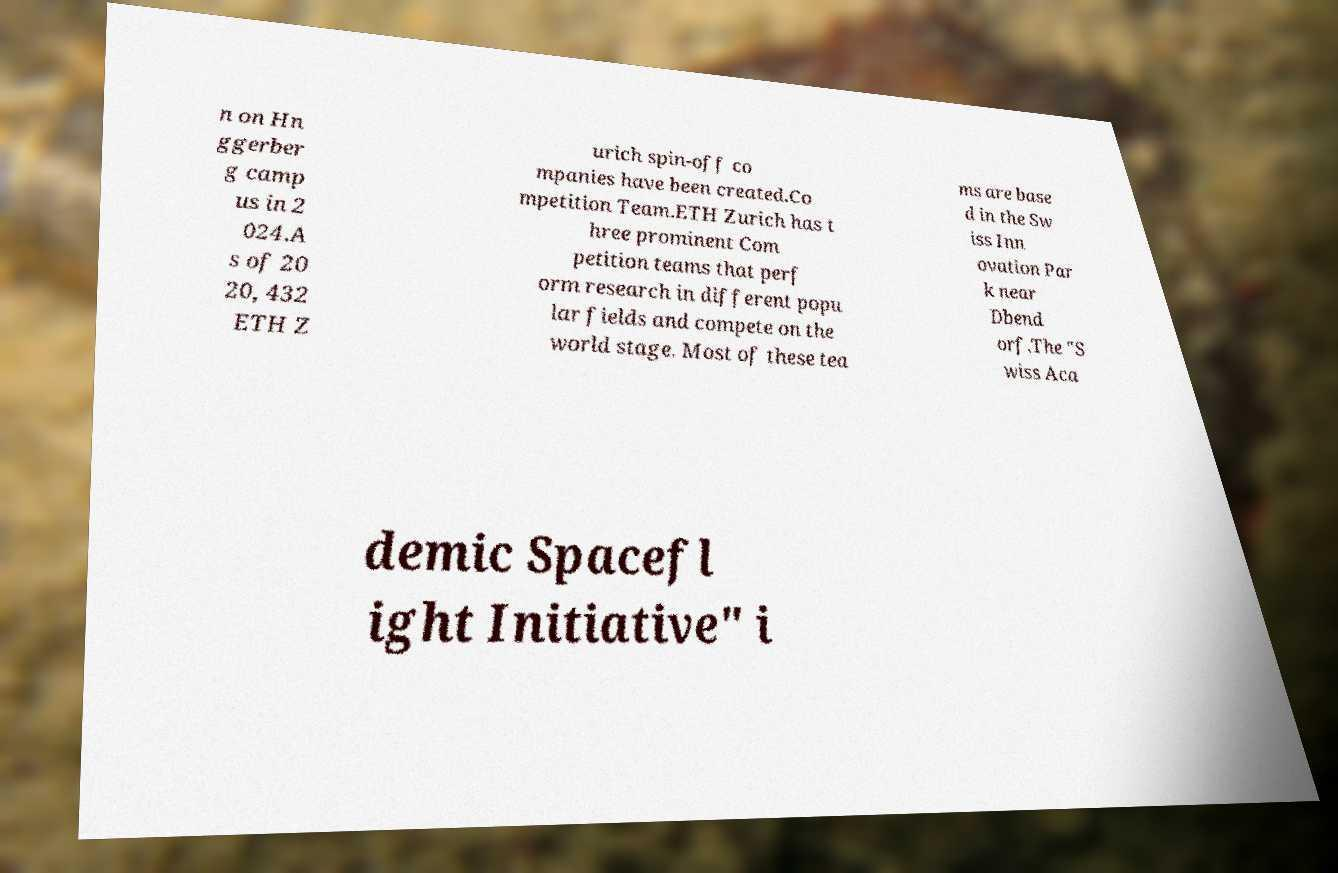Please read and relay the text visible in this image. What does it say? n on Hn ggerber g camp us in 2 024.A s of 20 20, 432 ETH Z urich spin-off co mpanies have been created.Co mpetition Team.ETH Zurich has t hree prominent Com petition teams that perf orm research in different popu lar fields and compete on the world stage. Most of these tea ms are base d in the Sw iss Inn ovation Par k near Dbend orf.The "S wiss Aca demic Spacefl ight Initiative" i 